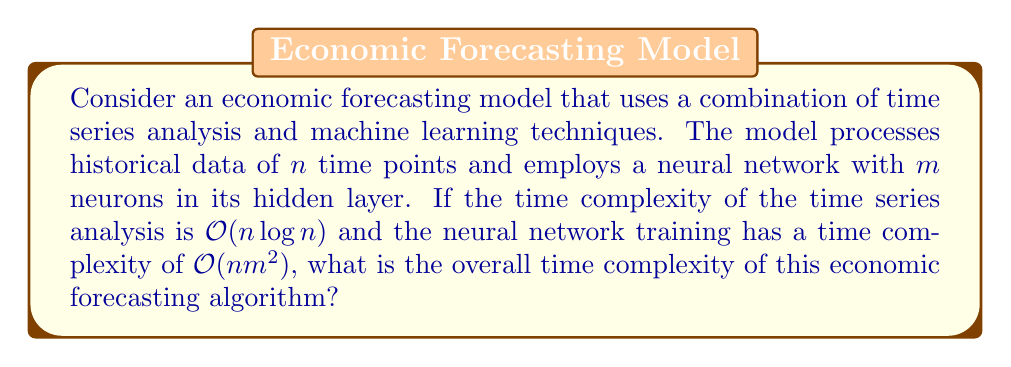Provide a solution to this math problem. To determine the overall time complexity of the economic forecasting algorithm, we need to analyze the individual components and combine them appropriately:

1. Time series analysis: $O(n \log n)$
2. Neural network training: $O(n m^2)$

The overall time complexity will be the sum of these two components, as they are executed sequentially:

$$T(n, m) = O(n \log n) + O(n m^2)$$

To simplify this expression, we need to determine which term dominates as $n$ and $m$ grow larger. We can compare the two terms:

$$n \log n \quad \text{vs} \quad n m^2$$

As $m$ increases, $n m^2$ will eventually become larger than $n \log n$ for any given $n$. Therefore, the $n m^2$ term dominates the overall time complexity.

In Big O notation, we keep only the dominant term. Thus, we can express the overall time complexity as:

$$T(n, m) = O(n m^2)$$

This result indicates that the neural network training is the most time-consuming part of the algorithm, and its complexity grows quadratically with the number of neurons in the hidden layer.
Answer: $O(n m^2)$ 